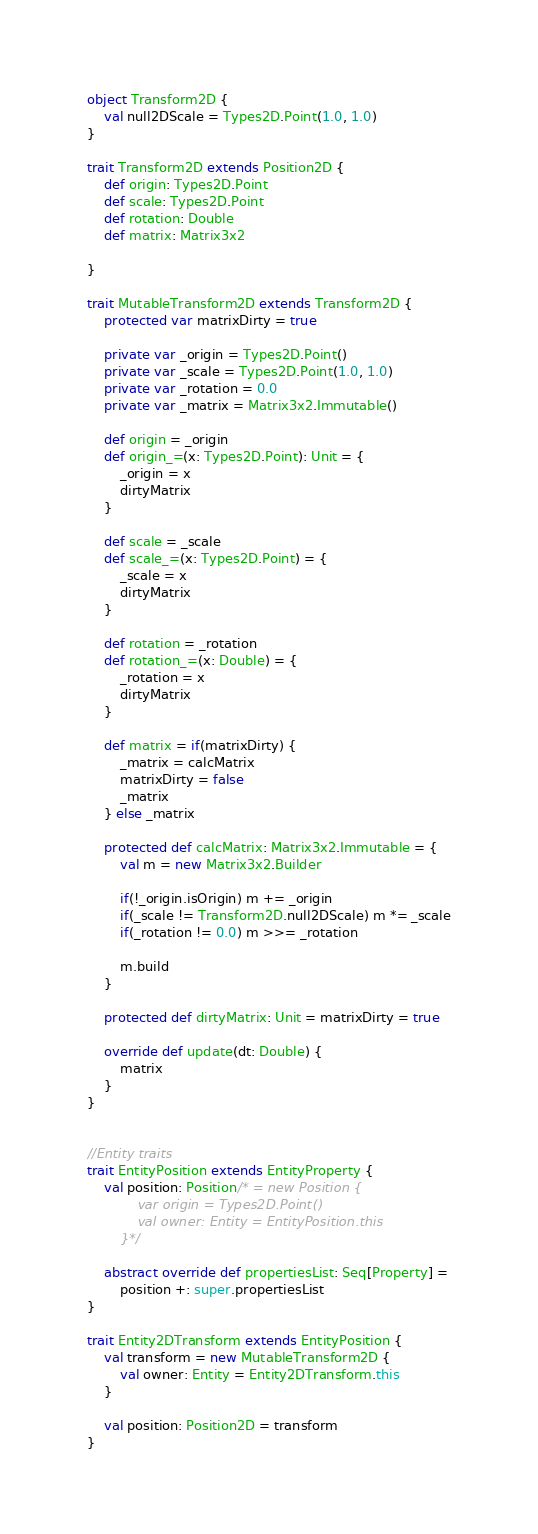<code> <loc_0><loc_0><loc_500><loc_500><_Scala_>object Transform2D {
    val null2DScale = Types2D.Point(1.0, 1.0)
}

trait Transform2D extends Position2D {
    def origin: Types2D.Point
    def scale: Types2D.Point
    def rotation: Double
    def matrix: Matrix3x2

}

trait MutableTransform2D extends Transform2D {
    protected var matrixDirty = true

    private var _origin = Types2D.Point()
    private var _scale = Types2D.Point(1.0, 1.0)
    private var _rotation = 0.0
    private var _matrix = Matrix3x2.Immutable()

    def origin = _origin
    def origin_=(x: Types2D.Point): Unit = {
        _origin = x
        dirtyMatrix
    }

    def scale = _scale
    def scale_=(x: Types2D.Point) = {
        _scale = x
        dirtyMatrix
    }

    def rotation = _rotation
    def rotation_=(x: Double) = {
        _rotation = x
        dirtyMatrix
    }

    def matrix = if(matrixDirty) {
        _matrix = calcMatrix
        matrixDirty = false
        _matrix
    } else _matrix

    protected def calcMatrix: Matrix3x2.Immutable = {
        val m = new Matrix3x2.Builder

        if(!_origin.isOrigin) m += _origin
        if(_scale != Transform2D.null2DScale) m *= _scale
        if(_rotation != 0.0) m >>= _rotation

        m.build
    }

    protected def dirtyMatrix: Unit = matrixDirty = true

    override def update(dt: Double) {
        matrix
    }
}


//Entity traits
trait EntityPosition extends EntityProperty {
    val position: Position/* = new Position {
            var origin = Types2D.Point()
            val owner: Entity = EntityPosition.this
        }*/

    abstract override def propertiesList: Seq[Property] =
        position +: super.propertiesList
}

trait Entity2DTransform extends EntityPosition {
    val transform = new MutableTransform2D {
        val owner: Entity = Entity2DTransform.this
    }

    val position: Position2D = transform
}</code> 